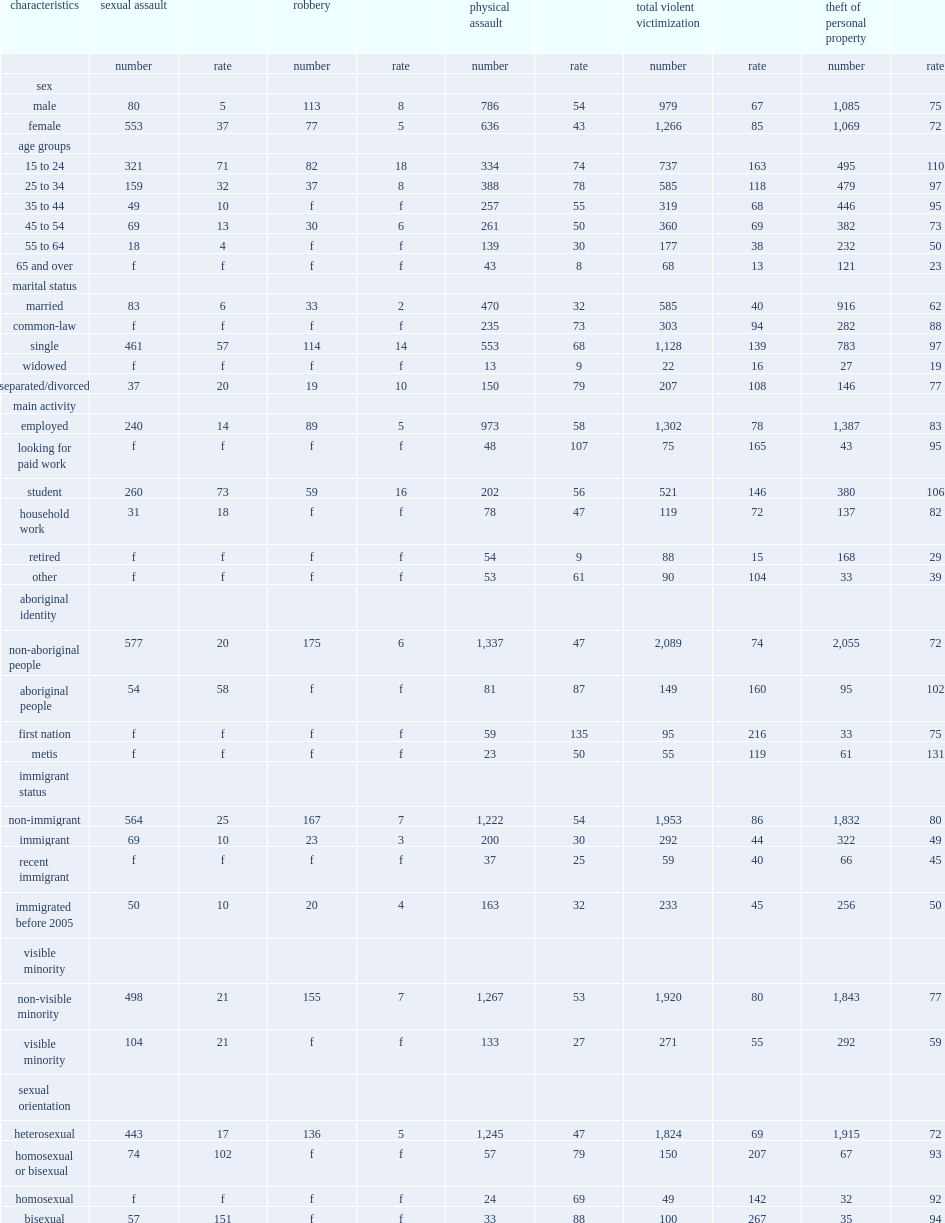In 2014, which gender record a higher violent victimization, women or men? Female. 